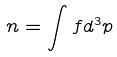<formula> <loc_0><loc_0><loc_500><loc_500>n = \int f d ^ { 3 } p</formula> 